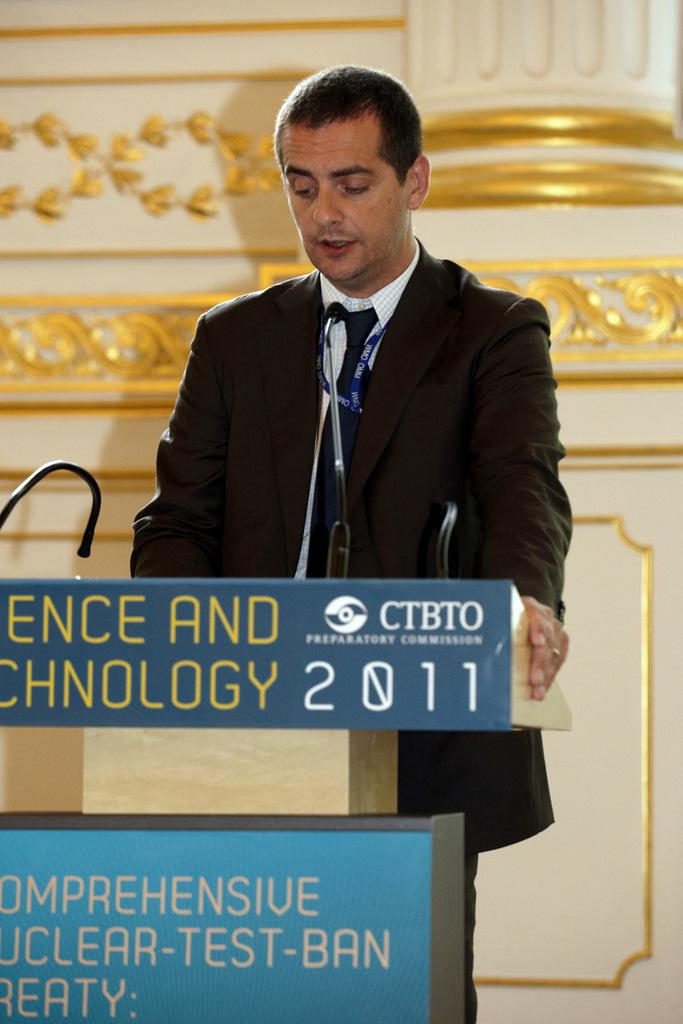What is the man in the image wearing? The man is wearing a suit. Where is the man located in the image? The man is standing near a speech desk. What can be seen on the speech desk? There are mice and posters on the speech desk. What is visible in the background of the image? There is a pillar and a wall visible in the background. How does the man make his payment for the prison sentence in the image? There is no mention of payment or prison in the image; it only features a man standing near a speech desk with mice and posters on it. 